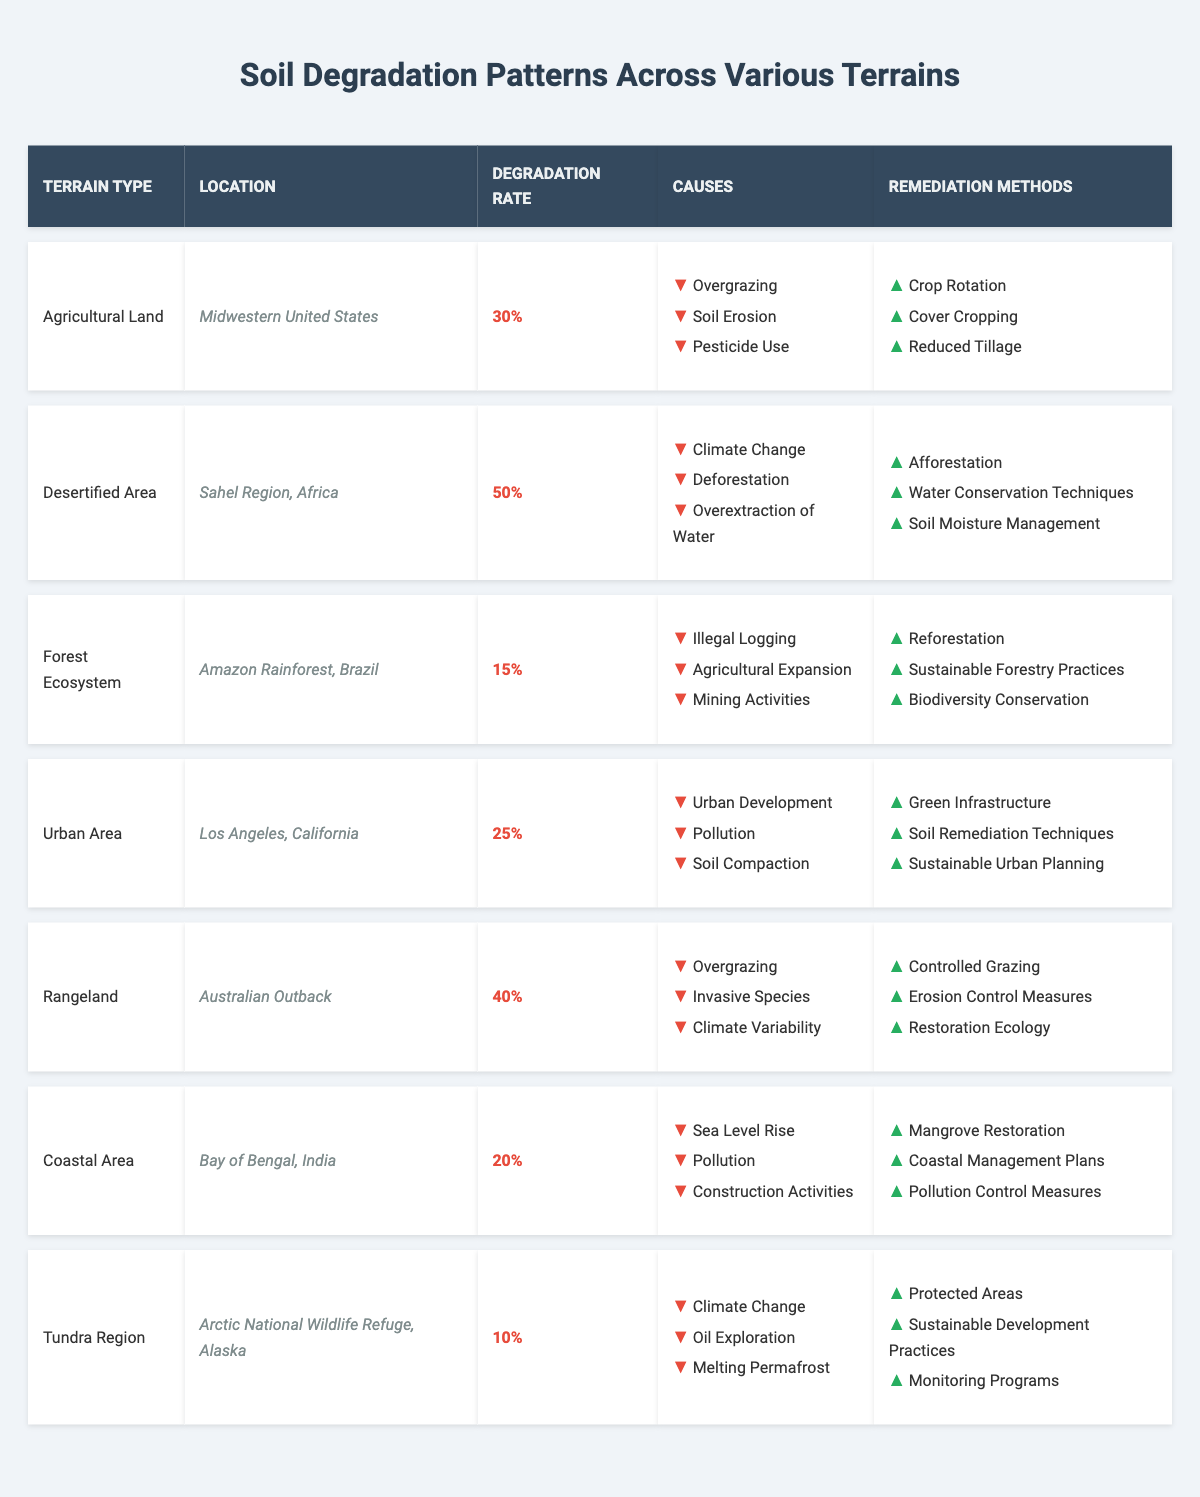What is the location of the desertified area? The table indicates that the desertified area is located in the Sahel Region, Africa.
Answer: Sahel Region, Africa What is the degradation rate for the forest ecosystem? According to the table, the degradation rate for the forest ecosystem in the Amazon Rainforest, Brazil is 15%.
Answer: 15% How many total soil degradation patterns are listed in the table? The table presents 7 different soil degradation patterns across various terrains.
Answer: 7 Which terrain type has the highest degradation rate? The highest degradation rate is 50%, which corresponds to the desertified area in the Sahel Region, Africa.
Answer: Desertified Area Is urban development a cause of soil degradation in urban areas? Yes, the table lists urban development as one of the causes of soil degradation in the urban area of Los Angeles, California.
Answer: Yes What is the average degradation rate across all terrain types? Summing the degradation rates (30% + 50% + 15% + 25% + 40% + 20% + 10%) gives 190%. Dividing by 7, the average degradation rate is approximately 27.14%.
Answer: 27.14% What are two remediation methods for rangeland degradation? The table provides two remediation methods for rangeland degradation: Controlled Grazing and Erosion Control Measures.
Answer: Controlled Grazing and Erosion Control Measures Which two terrains both show evidence of climate-related causes for degradation? The tundra region and the desertified area both list climate change as one of their causes for soil degradation.
Answer: Tundra Region and Desertified Area What remediation method is common to both coastal areas and forest ecosystems? Both coastal areas and forest ecosystems indicate the need for restoration practices, specifically mangrove restoration and reforestation, respectively.
Answer: None (they don't share a remediation method) How does the degradation rate in the Amazon Rainforest compare to that in the Australian Outback? The Amazon Rainforest has a degradation rate of 15%, while the Australian Outback has a rate of 40%. Therefore, the outback is significantly higher.
Answer: Amazon: 15%, Outback: 40% 